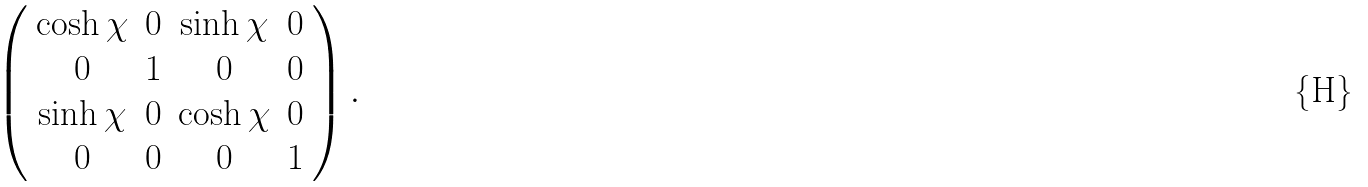<formula> <loc_0><loc_0><loc_500><loc_500>\left ( \begin{array} { c c c c } \cosh \chi & 0 & \sinh \chi & 0 \\ 0 & 1 & 0 & 0 \\ \sinh \chi & 0 & \cosh \chi & 0 \\ 0 & 0 & 0 & 1 \end{array} \right ) .</formula> 